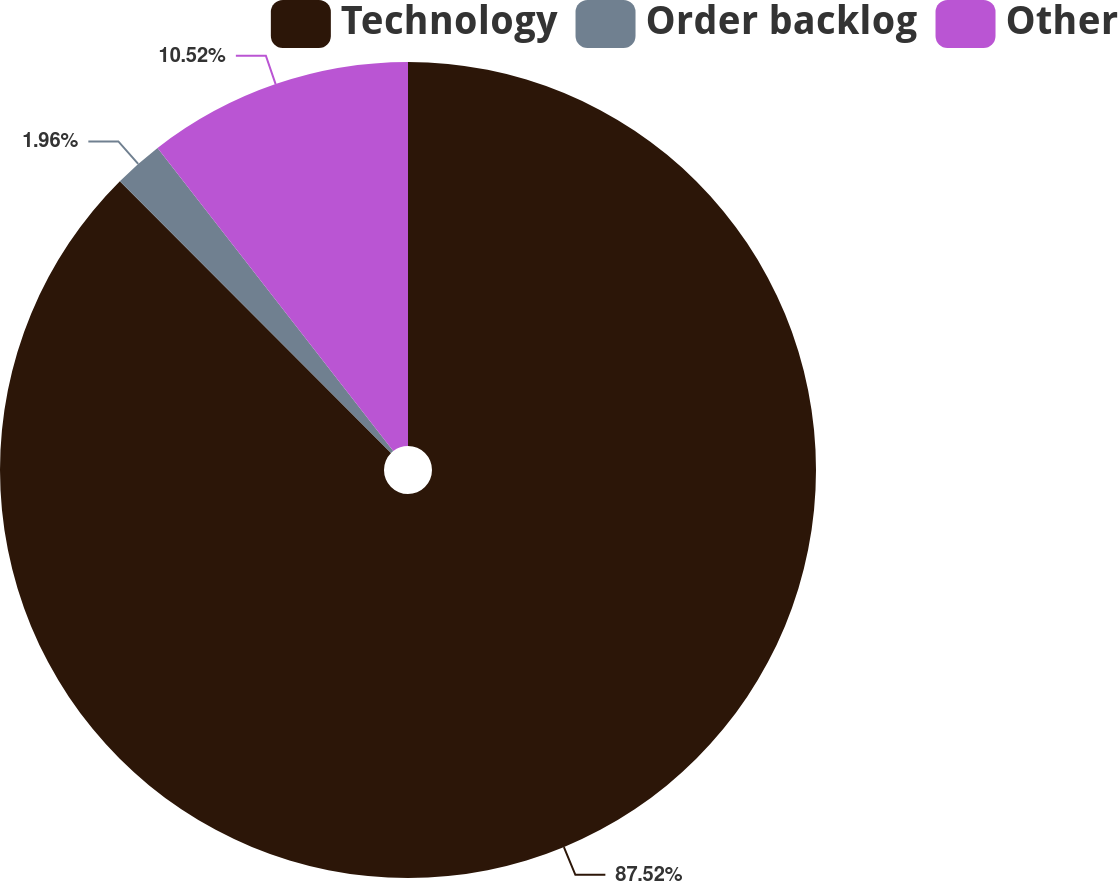Convert chart to OTSL. <chart><loc_0><loc_0><loc_500><loc_500><pie_chart><fcel>Technology<fcel>Order backlog<fcel>Other<nl><fcel>87.52%<fcel>1.96%<fcel>10.52%<nl></chart> 